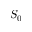Convert formula to latex. <formula><loc_0><loc_0><loc_500><loc_500>S _ { 0 }</formula> 